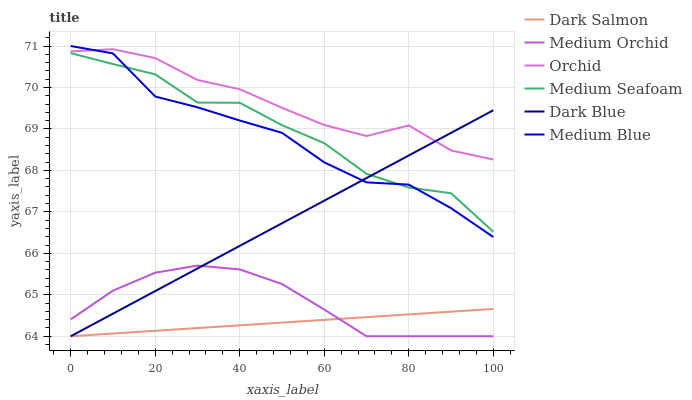Does Dark Salmon have the minimum area under the curve?
Answer yes or no. Yes. Does Orchid have the maximum area under the curve?
Answer yes or no. Yes. Does Medium Blue have the minimum area under the curve?
Answer yes or no. No. Does Medium Blue have the maximum area under the curve?
Answer yes or no. No. Is Dark Salmon the smoothest?
Answer yes or no. Yes. Is Medium Seafoam the roughest?
Answer yes or no. Yes. Is Medium Blue the smoothest?
Answer yes or no. No. Is Medium Blue the roughest?
Answer yes or no. No. Does Medium Orchid have the lowest value?
Answer yes or no. Yes. Does Medium Blue have the lowest value?
Answer yes or no. No. Does Medium Blue have the highest value?
Answer yes or no. Yes. Does Dark Salmon have the highest value?
Answer yes or no. No. Is Medium Orchid less than Orchid?
Answer yes or no. Yes. Is Medium Blue greater than Medium Orchid?
Answer yes or no. Yes. Does Medium Orchid intersect Dark Salmon?
Answer yes or no. Yes. Is Medium Orchid less than Dark Salmon?
Answer yes or no. No. Is Medium Orchid greater than Dark Salmon?
Answer yes or no. No. Does Medium Orchid intersect Orchid?
Answer yes or no. No. 